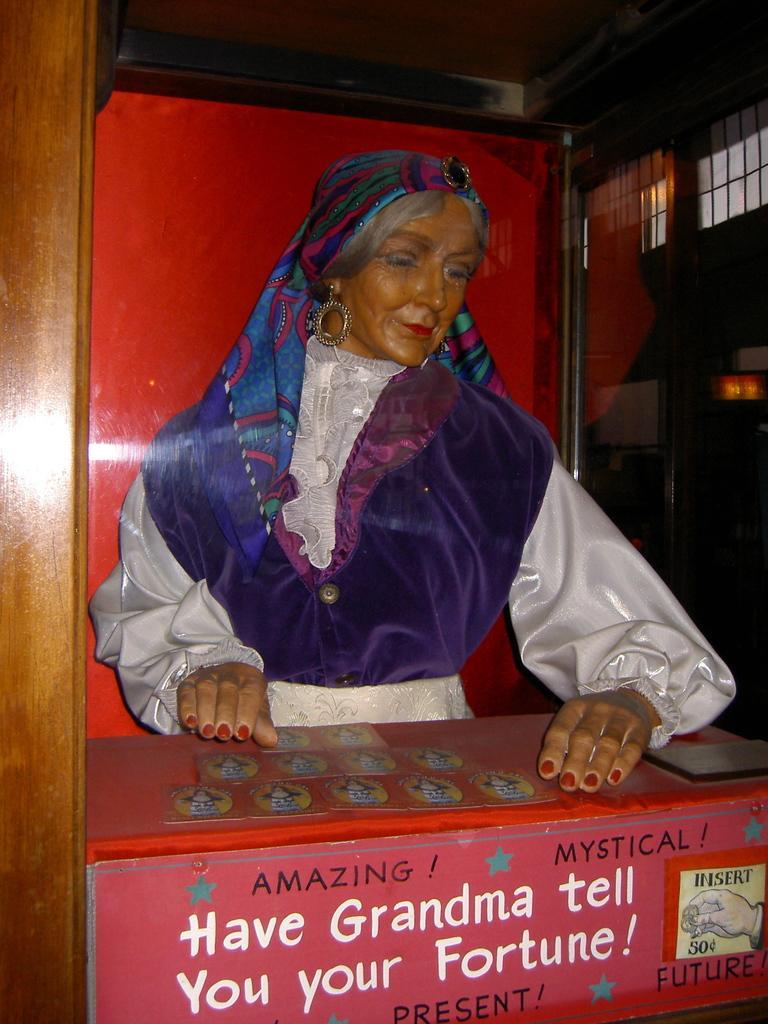Please provide a concise description of this image. In this image in the foreground there is a sculpture visible in front of desk, on which there is a text and person's hand, behind the sculpture there is a red color wall, on the right side there is a window, light, the wall. 